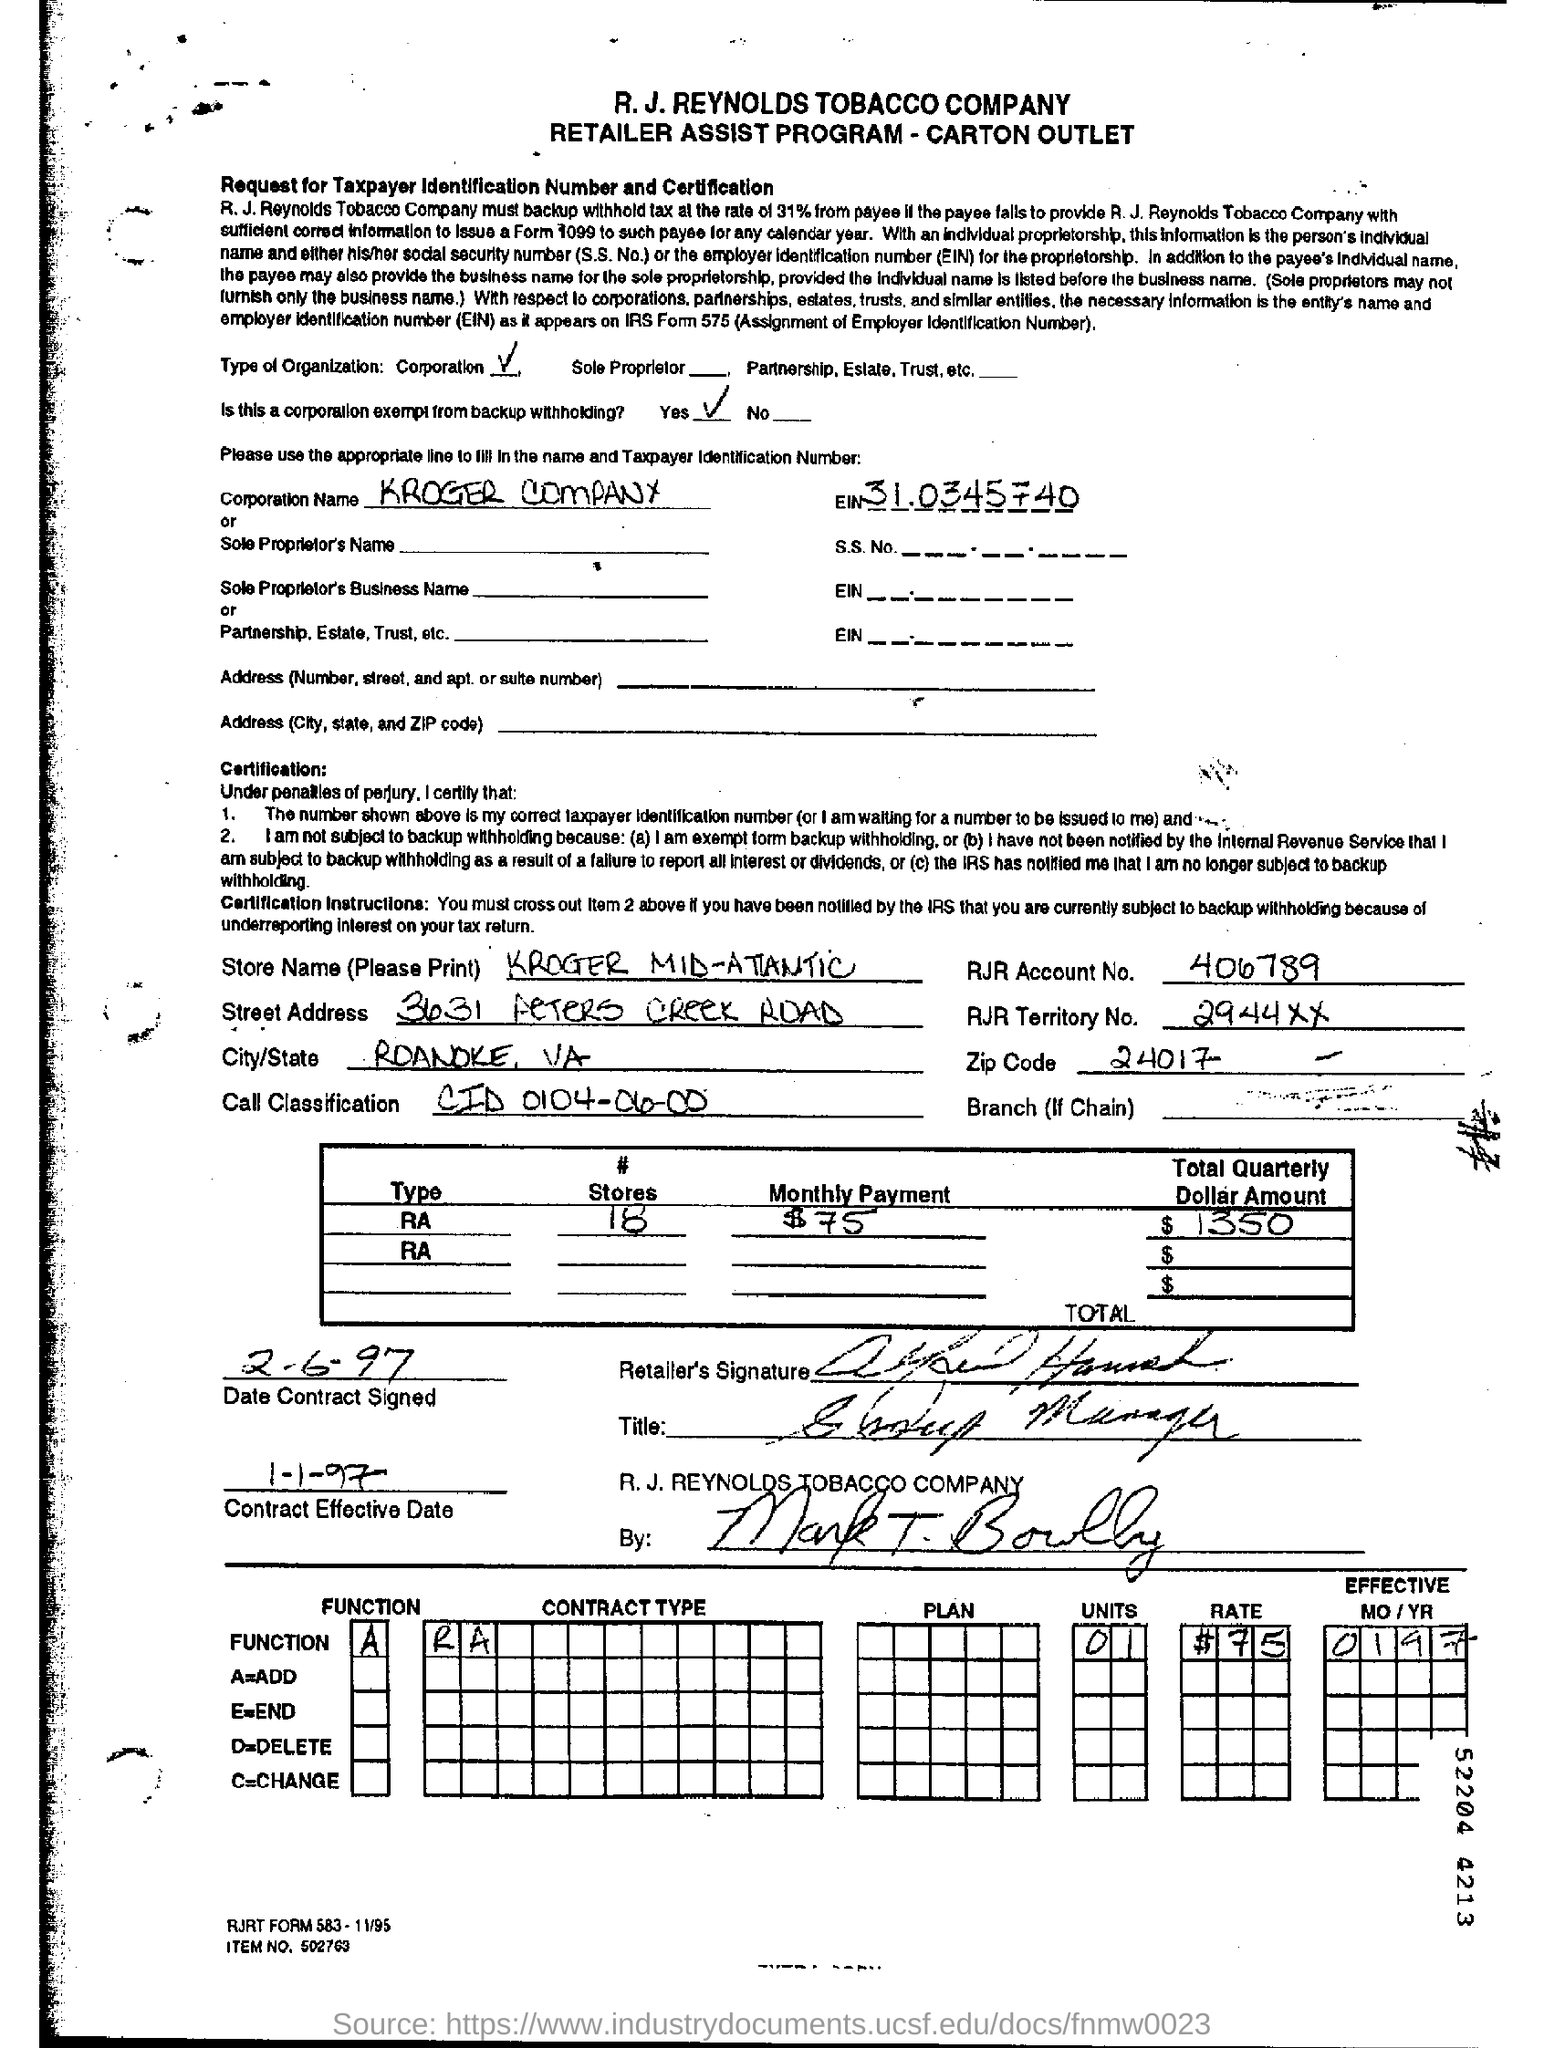Find out the date on which the contract became effective?
Your answer should be compact. 1-1-97. What is zip code mentioned in the document?
Ensure brevity in your answer.  24017. What is RJR Account No:?
Provide a succinct answer. 406789. Is this a corporation exempt from backup withholding?
Offer a terse response. Yes. What is the name of Corporation mentioned?
Your answer should be very brief. KROGER COMPANY. What is EIN number?
Your response must be concise. 31.0345740. What is the name of the store?
Provide a succinct answer. Kroger Mid Atlatic. 